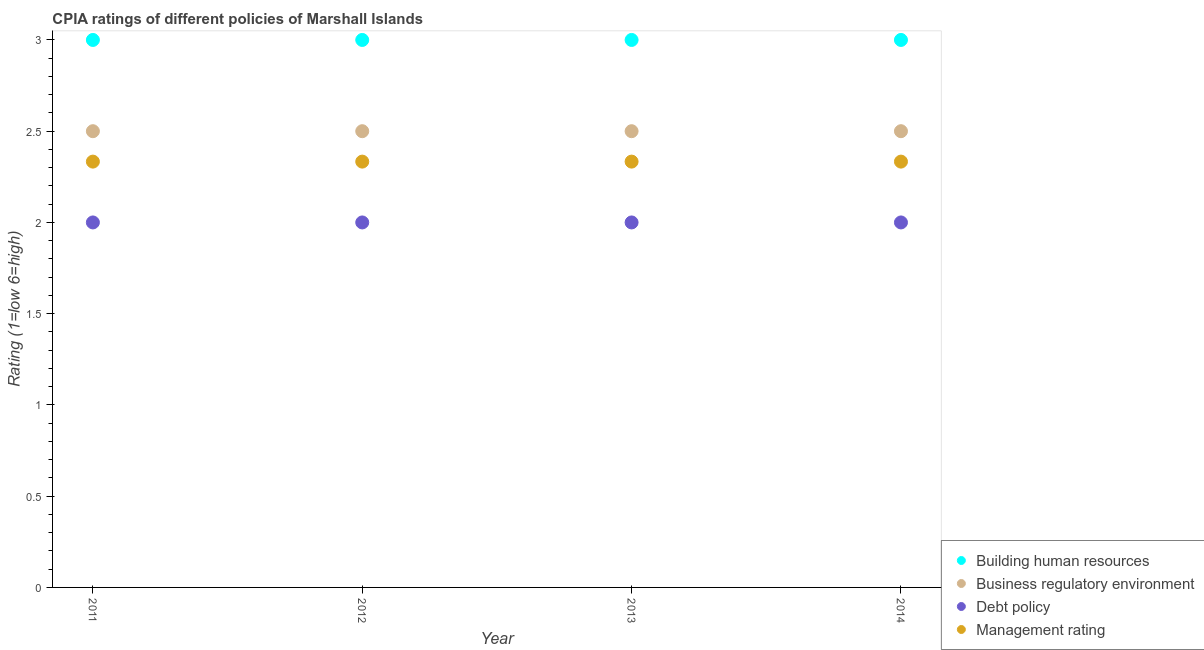What is the cpia rating of debt policy in 2012?
Provide a succinct answer. 2. Across all years, what is the maximum cpia rating of debt policy?
Ensure brevity in your answer.  2. Across all years, what is the minimum cpia rating of management?
Ensure brevity in your answer.  2.33. What is the total cpia rating of debt policy in the graph?
Your answer should be very brief. 8. What is the difference between the cpia rating of debt policy in 2011 and that in 2013?
Keep it short and to the point. 0. What is the difference between the cpia rating of building human resources in 2014 and the cpia rating of management in 2012?
Keep it short and to the point. 0.67. What is the average cpia rating of building human resources per year?
Your answer should be very brief. 3. In the year 2014, what is the difference between the cpia rating of debt policy and cpia rating of building human resources?
Ensure brevity in your answer.  -1. What is the ratio of the cpia rating of management in 2012 to that in 2014?
Provide a succinct answer. 1. What is the difference between the highest and the second highest cpia rating of debt policy?
Give a very brief answer. 0. What is the difference between the highest and the lowest cpia rating of management?
Ensure brevity in your answer.  3.333333329802457e-6. Does the cpia rating of management monotonically increase over the years?
Your answer should be very brief. No. Is the cpia rating of business regulatory environment strictly greater than the cpia rating of building human resources over the years?
Your answer should be very brief. No. Is the cpia rating of business regulatory environment strictly less than the cpia rating of debt policy over the years?
Make the answer very short. No. How many dotlines are there?
Make the answer very short. 4. Does the graph contain any zero values?
Make the answer very short. No. How many legend labels are there?
Provide a succinct answer. 4. How are the legend labels stacked?
Ensure brevity in your answer.  Vertical. What is the title of the graph?
Your answer should be very brief. CPIA ratings of different policies of Marshall Islands. What is the Rating (1=low 6=high) of Business regulatory environment in 2011?
Give a very brief answer. 2.5. What is the Rating (1=low 6=high) in Management rating in 2011?
Your response must be concise. 2.33. What is the Rating (1=low 6=high) of Building human resources in 2012?
Give a very brief answer. 3. What is the Rating (1=low 6=high) in Management rating in 2012?
Your answer should be very brief. 2.33. What is the Rating (1=low 6=high) of Building human resources in 2013?
Your response must be concise. 3. What is the Rating (1=low 6=high) of Debt policy in 2013?
Your response must be concise. 2. What is the Rating (1=low 6=high) in Management rating in 2013?
Ensure brevity in your answer.  2.33. What is the Rating (1=low 6=high) in Debt policy in 2014?
Provide a short and direct response. 2. What is the Rating (1=low 6=high) in Management rating in 2014?
Your response must be concise. 2.33. Across all years, what is the maximum Rating (1=low 6=high) of Business regulatory environment?
Provide a succinct answer. 2.5. Across all years, what is the maximum Rating (1=low 6=high) of Management rating?
Provide a short and direct response. 2.33. Across all years, what is the minimum Rating (1=low 6=high) of Building human resources?
Your answer should be very brief. 3. Across all years, what is the minimum Rating (1=low 6=high) in Debt policy?
Provide a short and direct response. 2. Across all years, what is the minimum Rating (1=low 6=high) of Management rating?
Your response must be concise. 2.33. What is the total Rating (1=low 6=high) in Management rating in the graph?
Offer a very short reply. 9.33. What is the difference between the Rating (1=low 6=high) of Building human resources in 2011 and that in 2012?
Offer a very short reply. 0. What is the difference between the Rating (1=low 6=high) in Business regulatory environment in 2011 and that in 2012?
Provide a succinct answer. 0. What is the difference between the Rating (1=low 6=high) in Debt policy in 2011 and that in 2012?
Make the answer very short. 0. What is the difference between the Rating (1=low 6=high) of Business regulatory environment in 2011 and that in 2013?
Provide a succinct answer. 0. What is the difference between the Rating (1=low 6=high) of Debt policy in 2011 and that in 2013?
Provide a succinct answer. 0. What is the difference between the Rating (1=low 6=high) of Building human resources in 2011 and that in 2014?
Your answer should be very brief. 0. What is the difference between the Rating (1=low 6=high) of Debt policy in 2011 and that in 2014?
Ensure brevity in your answer.  0. What is the difference between the Rating (1=low 6=high) in Business regulatory environment in 2012 and that in 2013?
Provide a succinct answer. 0. What is the difference between the Rating (1=low 6=high) of Debt policy in 2012 and that in 2013?
Ensure brevity in your answer.  0. What is the difference between the Rating (1=low 6=high) of Management rating in 2012 and that in 2013?
Ensure brevity in your answer.  0. What is the difference between the Rating (1=low 6=high) in Building human resources in 2012 and that in 2014?
Give a very brief answer. 0. What is the difference between the Rating (1=low 6=high) of Business regulatory environment in 2012 and that in 2014?
Make the answer very short. 0. What is the difference between the Rating (1=low 6=high) in Business regulatory environment in 2013 and that in 2014?
Make the answer very short. 0. What is the difference between the Rating (1=low 6=high) of Debt policy in 2013 and that in 2014?
Your answer should be compact. 0. What is the difference between the Rating (1=low 6=high) in Management rating in 2013 and that in 2014?
Keep it short and to the point. 0. What is the difference between the Rating (1=low 6=high) of Business regulatory environment in 2011 and the Rating (1=low 6=high) of Debt policy in 2012?
Provide a short and direct response. 0.5. What is the difference between the Rating (1=low 6=high) in Business regulatory environment in 2011 and the Rating (1=low 6=high) in Management rating in 2012?
Your answer should be very brief. 0.17. What is the difference between the Rating (1=low 6=high) in Debt policy in 2011 and the Rating (1=low 6=high) in Management rating in 2012?
Your answer should be compact. -0.33. What is the difference between the Rating (1=low 6=high) of Building human resources in 2011 and the Rating (1=low 6=high) of Business regulatory environment in 2013?
Your answer should be compact. 0.5. What is the difference between the Rating (1=low 6=high) in Business regulatory environment in 2011 and the Rating (1=low 6=high) in Management rating in 2013?
Keep it short and to the point. 0.17. What is the difference between the Rating (1=low 6=high) in Building human resources in 2011 and the Rating (1=low 6=high) in Management rating in 2014?
Offer a very short reply. 0.67. What is the difference between the Rating (1=low 6=high) of Business regulatory environment in 2011 and the Rating (1=low 6=high) of Debt policy in 2014?
Give a very brief answer. 0.5. What is the difference between the Rating (1=low 6=high) in Debt policy in 2011 and the Rating (1=low 6=high) in Management rating in 2014?
Provide a short and direct response. -0.33. What is the difference between the Rating (1=low 6=high) of Building human resources in 2012 and the Rating (1=low 6=high) of Business regulatory environment in 2013?
Offer a very short reply. 0.5. What is the difference between the Rating (1=low 6=high) of Building human resources in 2012 and the Rating (1=low 6=high) of Debt policy in 2013?
Your answer should be compact. 1. What is the difference between the Rating (1=low 6=high) in Business regulatory environment in 2012 and the Rating (1=low 6=high) in Debt policy in 2013?
Ensure brevity in your answer.  0.5. What is the difference between the Rating (1=low 6=high) of Business regulatory environment in 2012 and the Rating (1=low 6=high) of Management rating in 2013?
Your response must be concise. 0.17. What is the difference between the Rating (1=low 6=high) of Debt policy in 2012 and the Rating (1=low 6=high) of Management rating in 2013?
Keep it short and to the point. -0.33. What is the difference between the Rating (1=low 6=high) of Building human resources in 2012 and the Rating (1=low 6=high) of Business regulatory environment in 2014?
Offer a very short reply. 0.5. What is the difference between the Rating (1=low 6=high) in Building human resources in 2012 and the Rating (1=low 6=high) in Debt policy in 2014?
Your response must be concise. 1. What is the difference between the Rating (1=low 6=high) of Building human resources in 2013 and the Rating (1=low 6=high) of Debt policy in 2014?
Your answer should be very brief. 1. What is the difference between the Rating (1=low 6=high) of Business regulatory environment in 2013 and the Rating (1=low 6=high) of Debt policy in 2014?
Provide a short and direct response. 0.5. What is the difference between the Rating (1=low 6=high) of Business regulatory environment in 2013 and the Rating (1=low 6=high) of Management rating in 2014?
Give a very brief answer. 0.17. What is the difference between the Rating (1=low 6=high) of Debt policy in 2013 and the Rating (1=low 6=high) of Management rating in 2014?
Provide a succinct answer. -0.33. What is the average Rating (1=low 6=high) in Building human resources per year?
Give a very brief answer. 3. What is the average Rating (1=low 6=high) of Business regulatory environment per year?
Your answer should be very brief. 2.5. What is the average Rating (1=low 6=high) in Management rating per year?
Provide a succinct answer. 2.33. In the year 2011, what is the difference between the Rating (1=low 6=high) of Building human resources and Rating (1=low 6=high) of Debt policy?
Provide a short and direct response. 1. In the year 2012, what is the difference between the Rating (1=low 6=high) of Building human resources and Rating (1=low 6=high) of Business regulatory environment?
Give a very brief answer. 0.5. In the year 2012, what is the difference between the Rating (1=low 6=high) in Building human resources and Rating (1=low 6=high) in Debt policy?
Give a very brief answer. 1. In the year 2012, what is the difference between the Rating (1=low 6=high) in Building human resources and Rating (1=low 6=high) in Management rating?
Your answer should be compact. 0.67. In the year 2012, what is the difference between the Rating (1=low 6=high) in Business regulatory environment and Rating (1=low 6=high) in Debt policy?
Your answer should be compact. 0.5. In the year 2013, what is the difference between the Rating (1=low 6=high) of Building human resources and Rating (1=low 6=high) of Business regulatory environment?
Provide a succinct answer. 0.5. In the year 2013, what is the difference between the Rating (1=low 6=high) in Business regulatory environment and Rating (1=low 6=high) in Management rating?
Make the answer very short. 0.17. In the year 2013, what is the difference between the Rating (1=low 6=high) of Debt policy and Rating (1=low 6=high) of Management rating?
Provide a short and direct response. -0.33. In the year 2014, what is the difference between the Rating (1=low 6=high) in Building human resources and Rating (1=low 6=high) in Debt policy?
Ensure brevity in your answer.  1. In the year 2014, what is the difference between the Rating (1=low 6=high) of Building human resources and Rating (1=low 6=high) of Management rating?
Provide a short and direct response. 0.67. In the year 2014, what is the difference between the Rating (1=low 6=high) of Debt policy and Rating (1=low 6=high) of Management rating?
Keep it short and to the point. -0.33. What is the ratio of the Rating (1=low 6=high) in Building human resources in 2011 to that in 2013?
Ensure brevity in your answer.  1. What is the ratio of the Rating (1=low 6=high) in Business regulatory environment in 2011 to that in 2013?
Your answer should be very brief. 1. What is the ratio of the Rating (1=low 6=high) in Management rating in 2011 to that in 2013?
Provide a succinct answer. 1. What is the ratio of the Rating (1=low 6=high) in Building human resources in 2011 to that in 2014?
Your response must be concise. 1. What is the ratio of the Rating (1=low 6=high) of Debt policy in 2011 to that in 2014?
Provide a succinct answer. 1. What is the ratio of the Rating (1=low 6=high) of Building human resources in 2012 to that in 2013?
Give a very brief answer. 1. What is the ratio of the Rating (1=low 6=high) of Management rating in 2012 to that in 2013?
Offer a terse response. 1. What is the ratio of the Rating (1=low 6=high) in Building human resources in 2012 to that in 2014?
Your answer should be compact. 1. What is the ratio of the Rating (1=low 6=high) of Debt policy in 2012 to that in 2014?
Offer a very short reply. 1. What is the ratio of the Rating (1=low 6=high) of Management rating in 2012 to that in 2014?
Give a very brief answer. 1. What is the ratio of the Rating (1=low 6=high) of Business regulatory environment in 2013 to that in 2014?
Provide a succinct answer. 1. What is the ratio of the Rating (1=low 6=high) in Debt policy in 2013 to that in 2014?
Keep it short and to the point. 1. What is the difference between the highest and the second highest Rating (1=low 6=high) of Building human resources?
Provide a short and direct response. 0. What is the difference between the highest and the second highest Rating (1=low 6=high) of Business regulatory environment?
Make the answer very short. 0. What is the difference between the highest and the lowest Rating (1=low 6=high) of Building human resources?
Ensure brevity in your answer.  0. What is the difference between the highest and the lowest Rating (1=low 6=high) in Business regulatory environment?
Offer a very short reply. 0. What is the difference between the highest and the lowest Rating (1=low 6=high) in Debt policy?
Offer a very short reply. 0. What is the difference between the highest and the lowest Rating (1=low 6=high) in Management rating?
Provide a succinct answer. 0. 